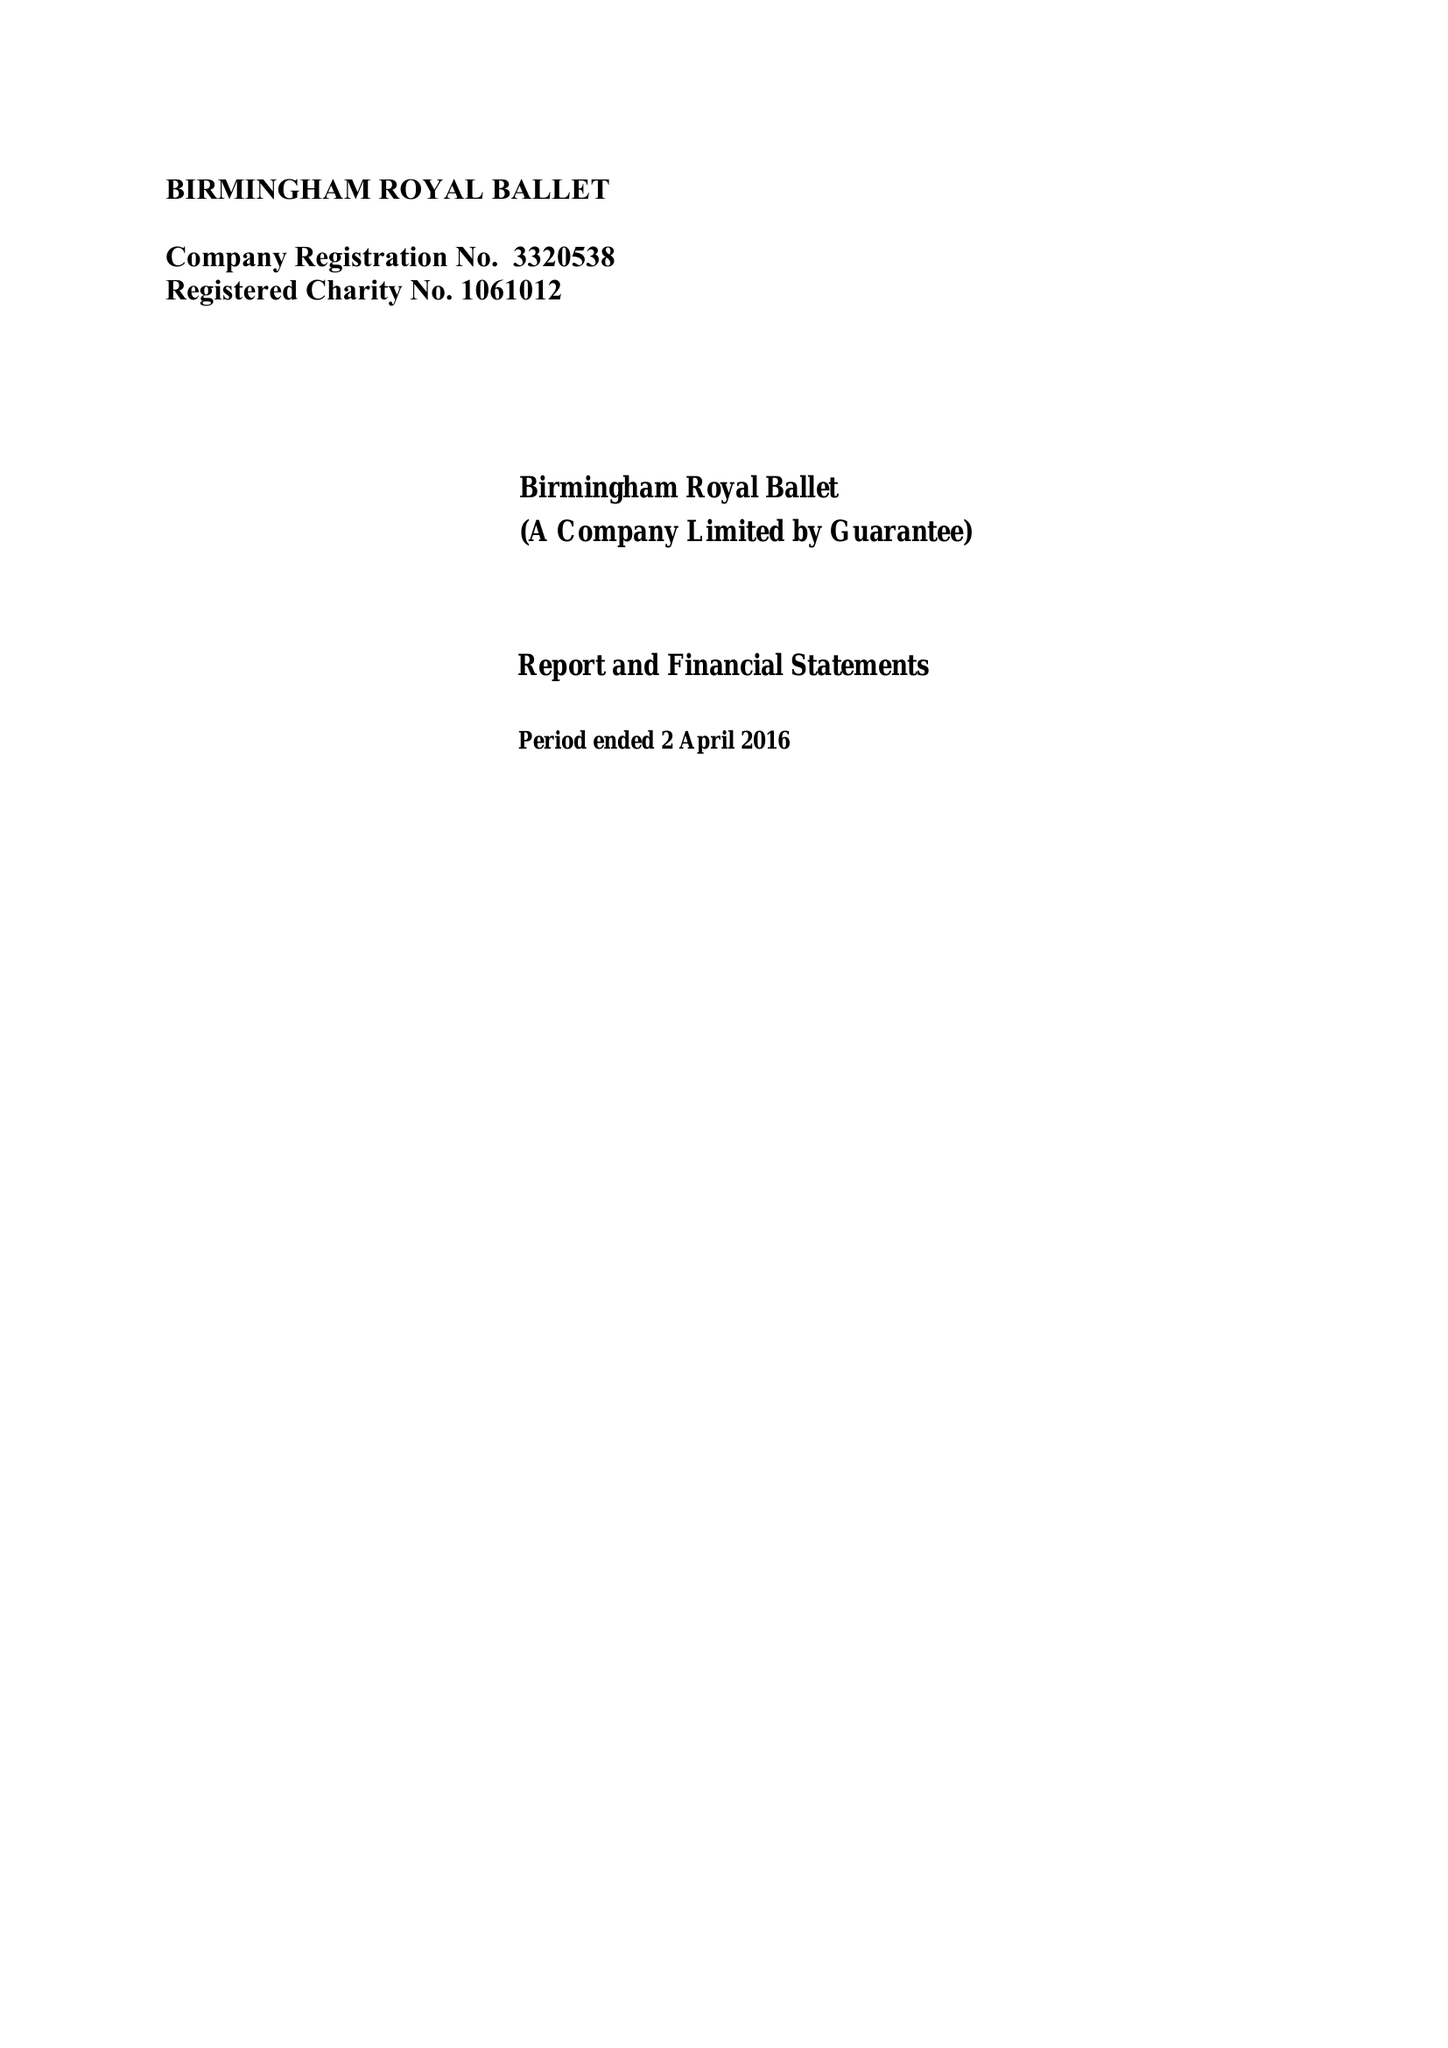What is the value for the address__postcode?
Answer the question using a single word or phrase. B5 4AU 